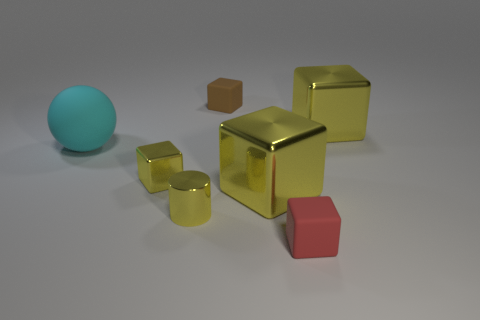How does the texture of the objects compare to each other? The objects display a variety of textures. The spherical object has a smooth, matte finish, while the cubes appear to have a reflective, metallic sheen, indicative of different surface properties. 